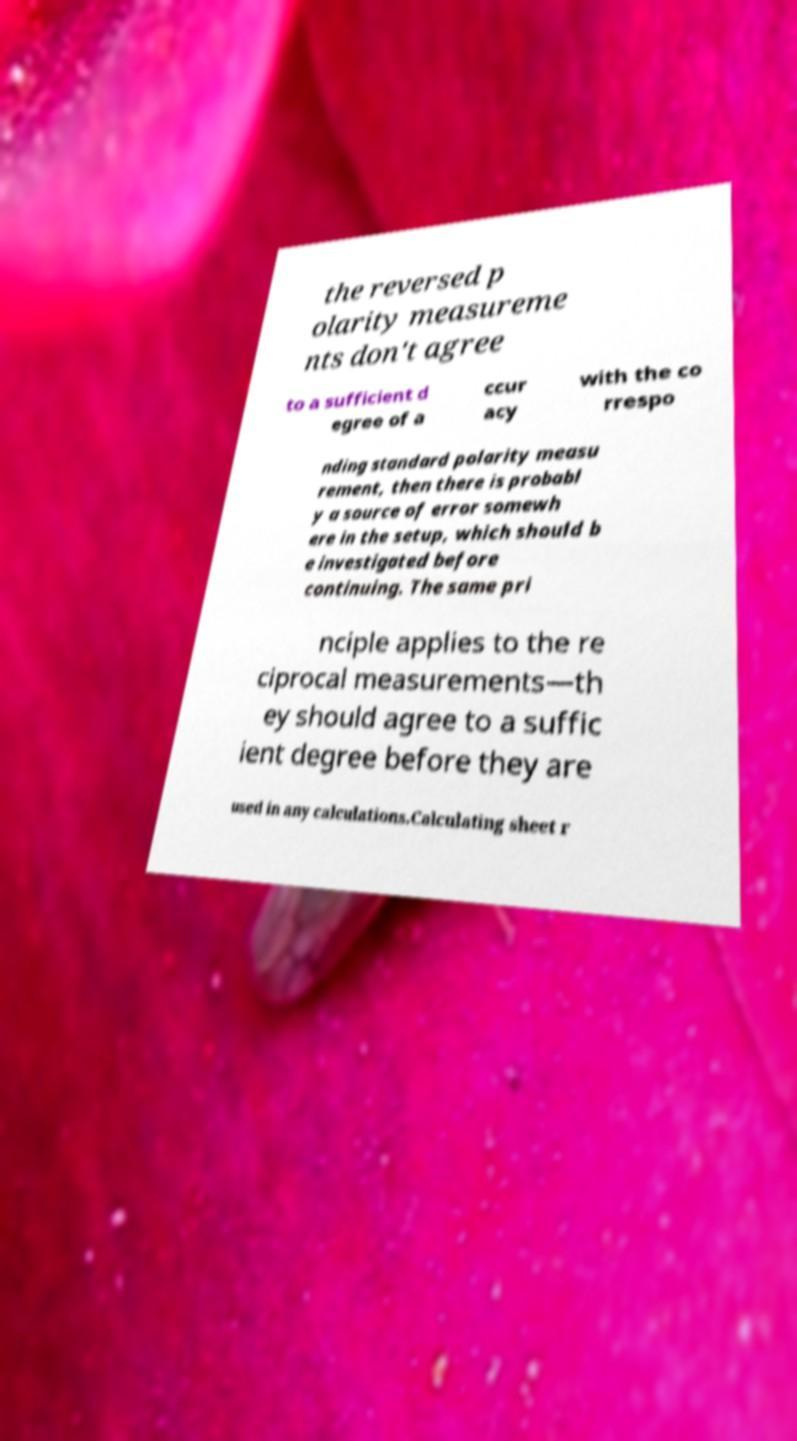Could you assist in decoding the text presented in this image and type it out clearly? the reversed p olarity measureme nts don't agree to a sufficient d egree of a ccur acy with the co rrespo nding standard polarity measu rement, then there is probabl y a source of error somewh ere in the setup, which should b e investigated before continuing. The same pri nciple applies to the re ciprocal measurements—th ey should agree to a suffic ient degree before they are used in any calculations.Calculating sheet r 